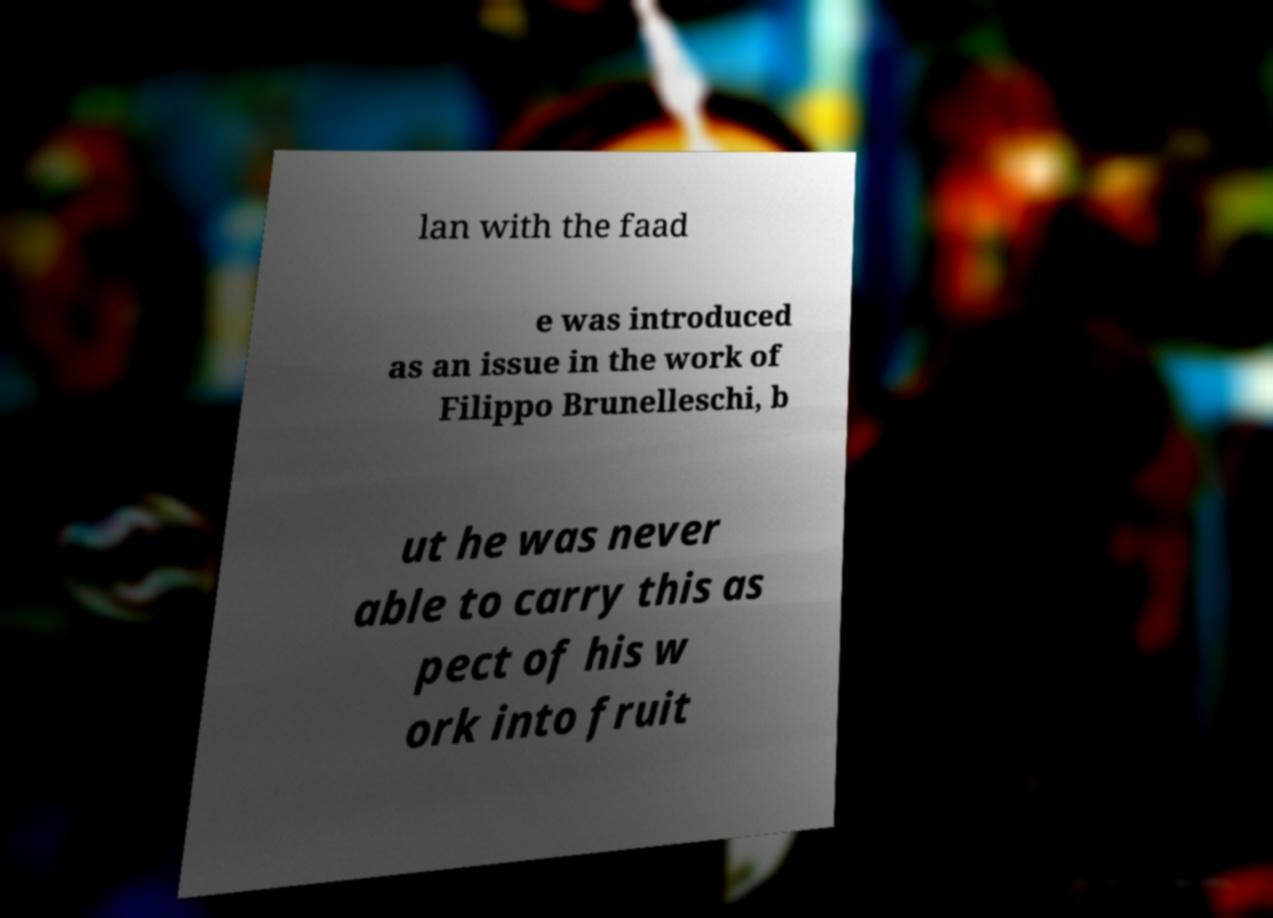What messages or text are displayed in this image? I need them in a readable, typed format. lan with the faad e was introduced as an issue in the work of Filippo Brunelleschi, b ut he was never able to carry this as pect of his w ork into fruit 